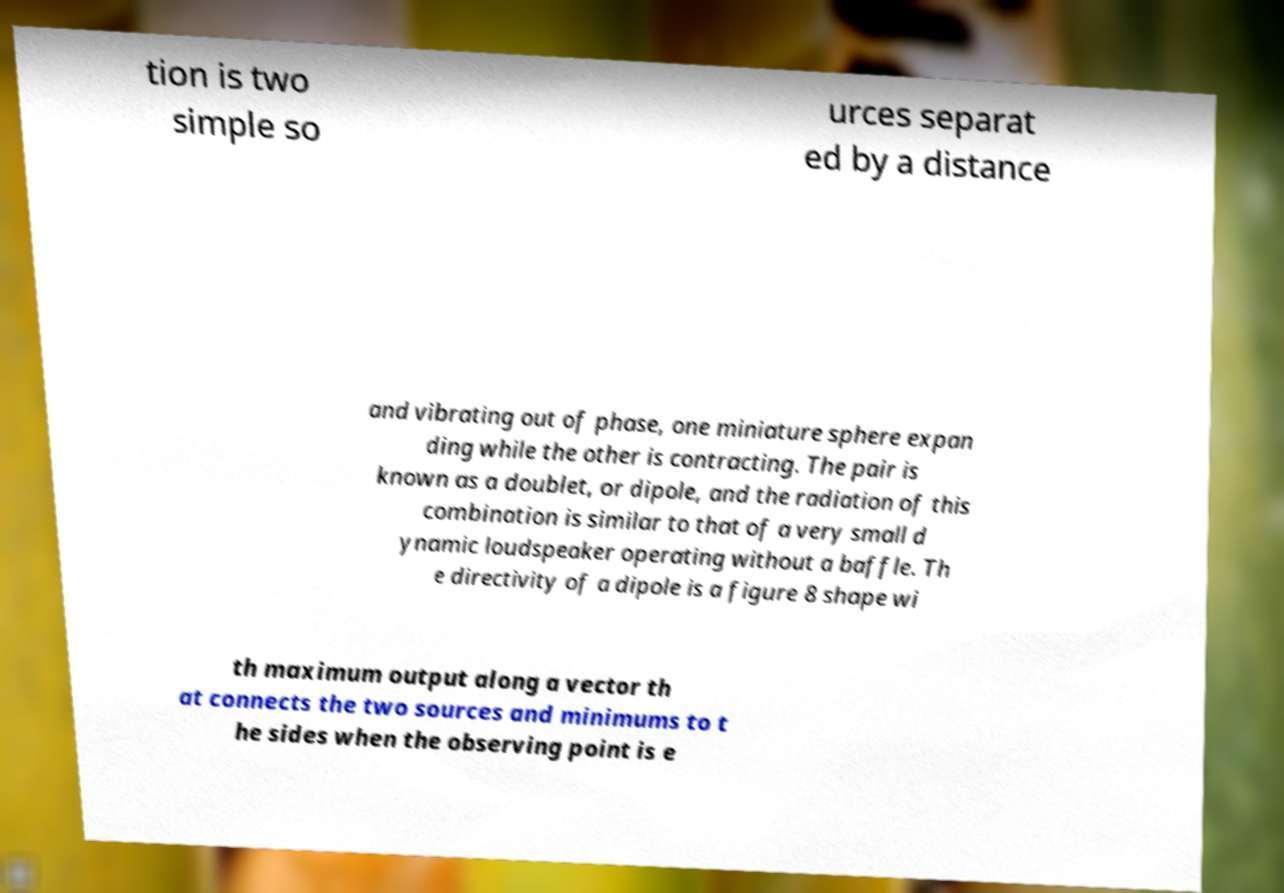What messages or text are displayed in this image? I need them in a readable, typed format. tion is two simple so urces separat ed by a distance and vibrating out of phase, one miniature sphere expan ding while the other is contracting. The pair is known as a doublet, or dipole, and the radiation of this combination is similar to that of a very small d ynamic loudspeaker operating without a baffle. Th e directivity of a dipole is a figure 8 shape wi th maximum output along a vector th at connects the two sources and minimums to t he sides when the observing point is e 